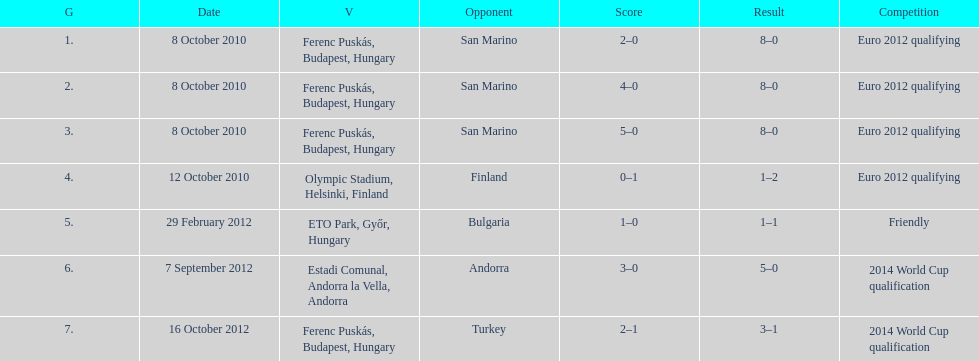In what year did ádám szalai make his next international goal after 2010? 2012. 